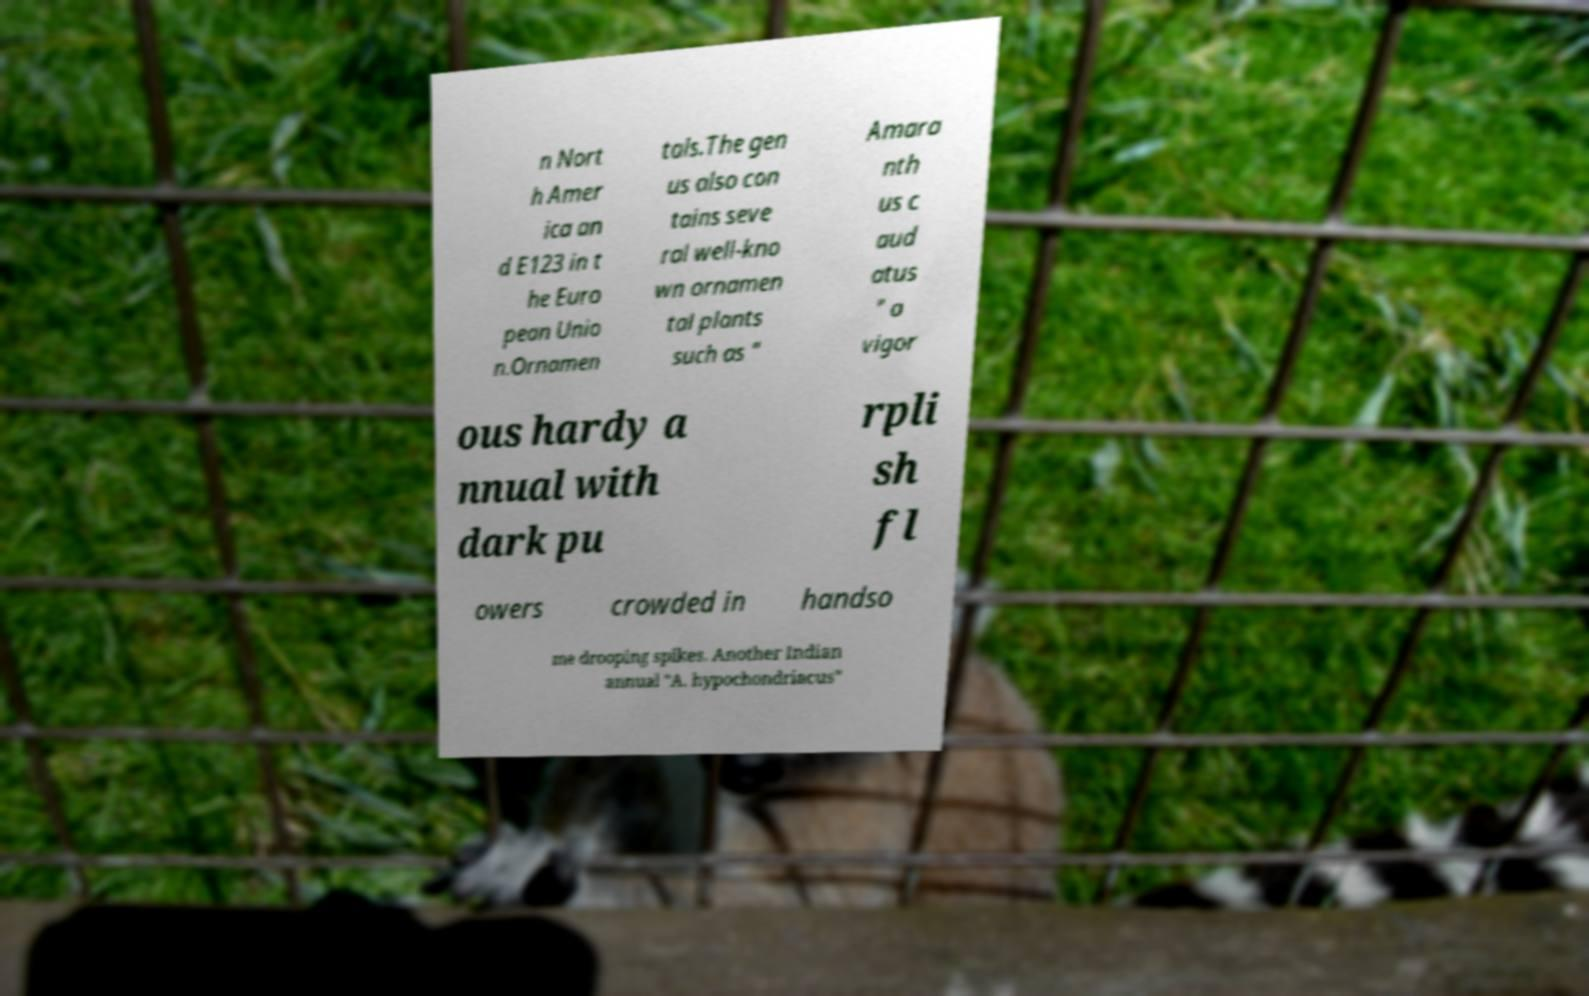For documentation purposes, I need the text within this image transcribed. Could you provide that? n Nort h Amer ica an d E123 in t he Euro pean Unio n.Ornamen tals.The gen us also con tains seve ral well-kno wn ornamen tal plants such as " Amara nth us c aud atus " a vigor ous hardy a nnual with dark pu rpli sh fl owers crowded in handso me drooping spikes. Another Indian annual "A. hypochondriacus" 